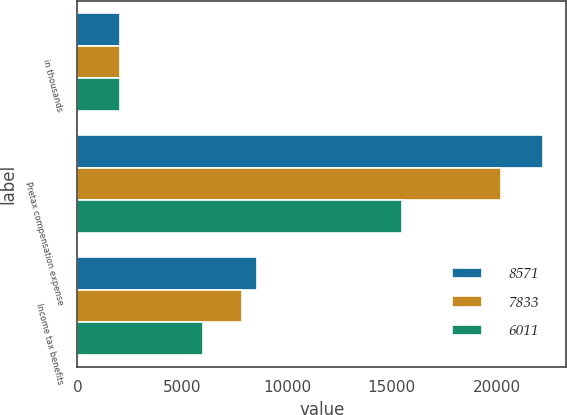Convert chart to OTSL. <chart><loc_0><loc_0><loc_500><loc_500><stacked_bar_chart><ecel><fcel>in thousands<fcel>Pretax compensation expense<fcel>Income tax benefits<nl><fcel>8571<fcel>2014<fcel>22217<fcel>8571<nl><fcel>7833<fcel>2013<fcel>20187<fcel>7833<nl><fcel>6011<fcel>2012<fcel>15491<fcel>6011<nl></chart> 